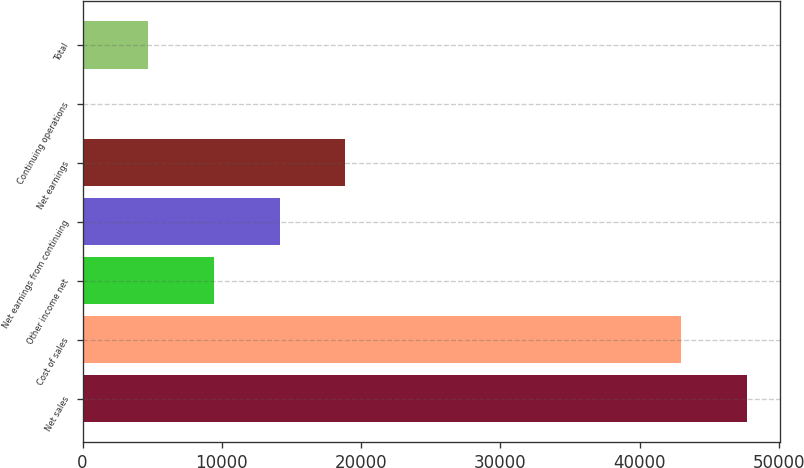<chart> <loc_0><loc_0><loc_500><loc_500><bar_chart><fcel>Net sales<fcel>Cost of sales<fcel>Other income net<fcel>Net earnings from continuing<fcel>Net earnings<fcel>Continuing operations<fcel>Total<nl><fcel>47703.4<fcel>42986<fcel>9443.08<fcel>14160.4<fcel>18877.8<fcel>8.36<fcel>4725.72<nl></chart> 